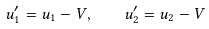<formula> <loc_0><loc_0><loc_500><loc_500>u _ { 1 } ^ { \prime } = u _ { 1 } - V , \quad u _ { 2 } ^ { \prime } = u _ { 2 } - V</formula> 